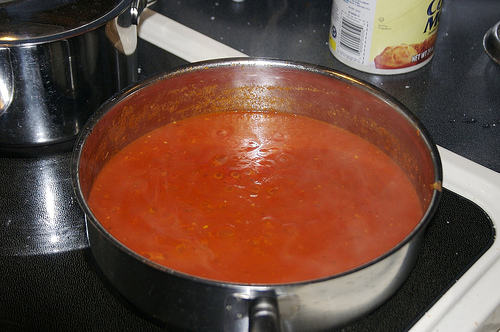<image>
Can you confirm if the soup is to the right of the stove? No. The soup is not to the right of the stove. The horizontal positioning shows a different relationship. 